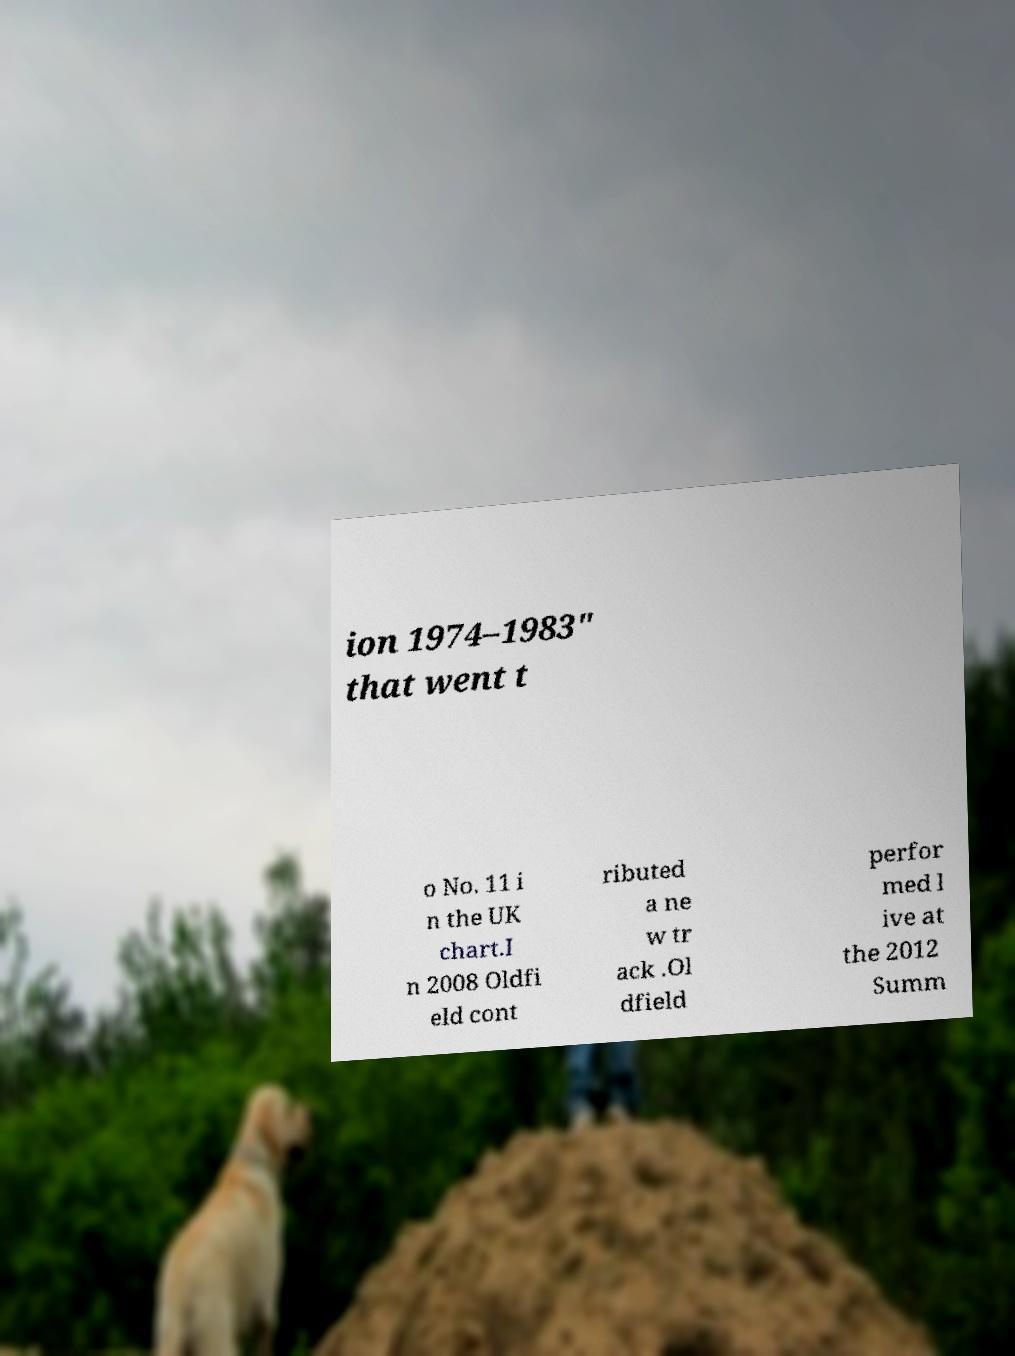Please read and relay the text visible in this image. What does it say? ion 1974–1983" that went t o No. 11 i n the UK chart.I n 2008 Oldfi eld cont ributed a ne w tr ack .Ol dfield perfor med l ive at the 2012 Summ 